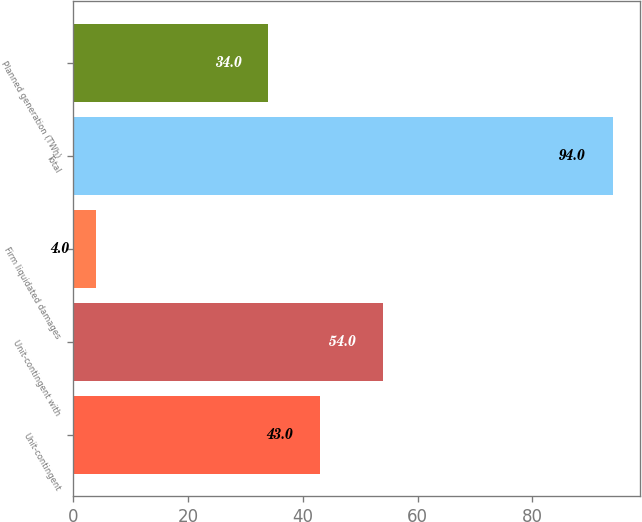Convert chart to OTSL. <chart><loc_0><loc_0><loc_500><loc_500><bar_chart><fcel>Unit-contingent<fcel>Unit-contingent with<fcel>Firm liquidated damages<fcel>Total<fcel>Planned generation (TWh)<nl><fcel>43<fcel>54<fcel>4<fcel>94<fcel>34<nl></chart> 